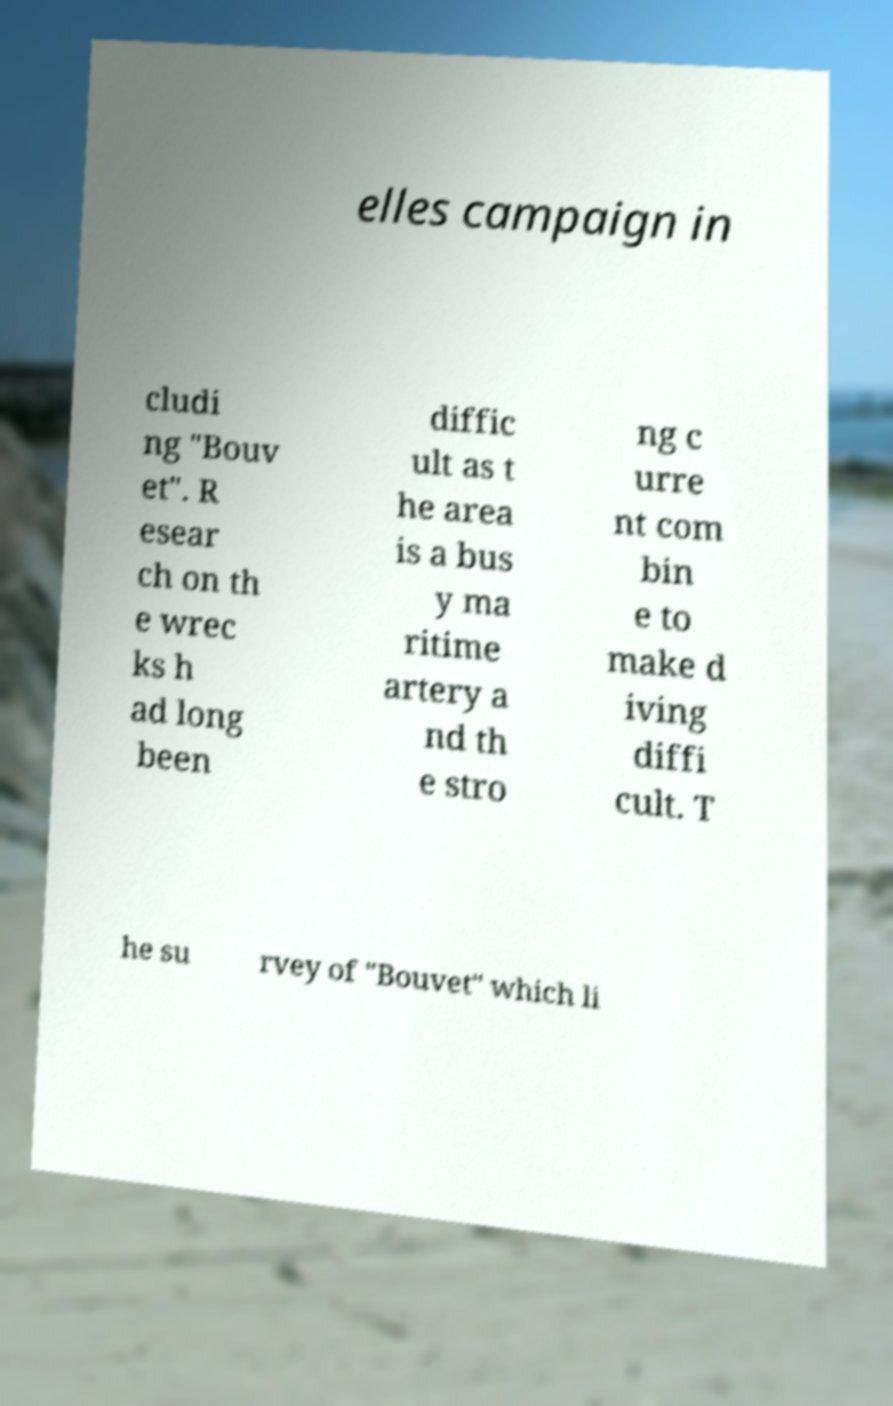Please identify and transcribe the text found in this image. elles campaign in cludi ng "Bouv et". R esear ch on th e wrec ks h ad long been diffic ult as t he area is a bus y ma ritime artery a nd th e stro ng c urre nt com bin e to make d iving diffi cult. T he su rvey of "Bouvet" which li 